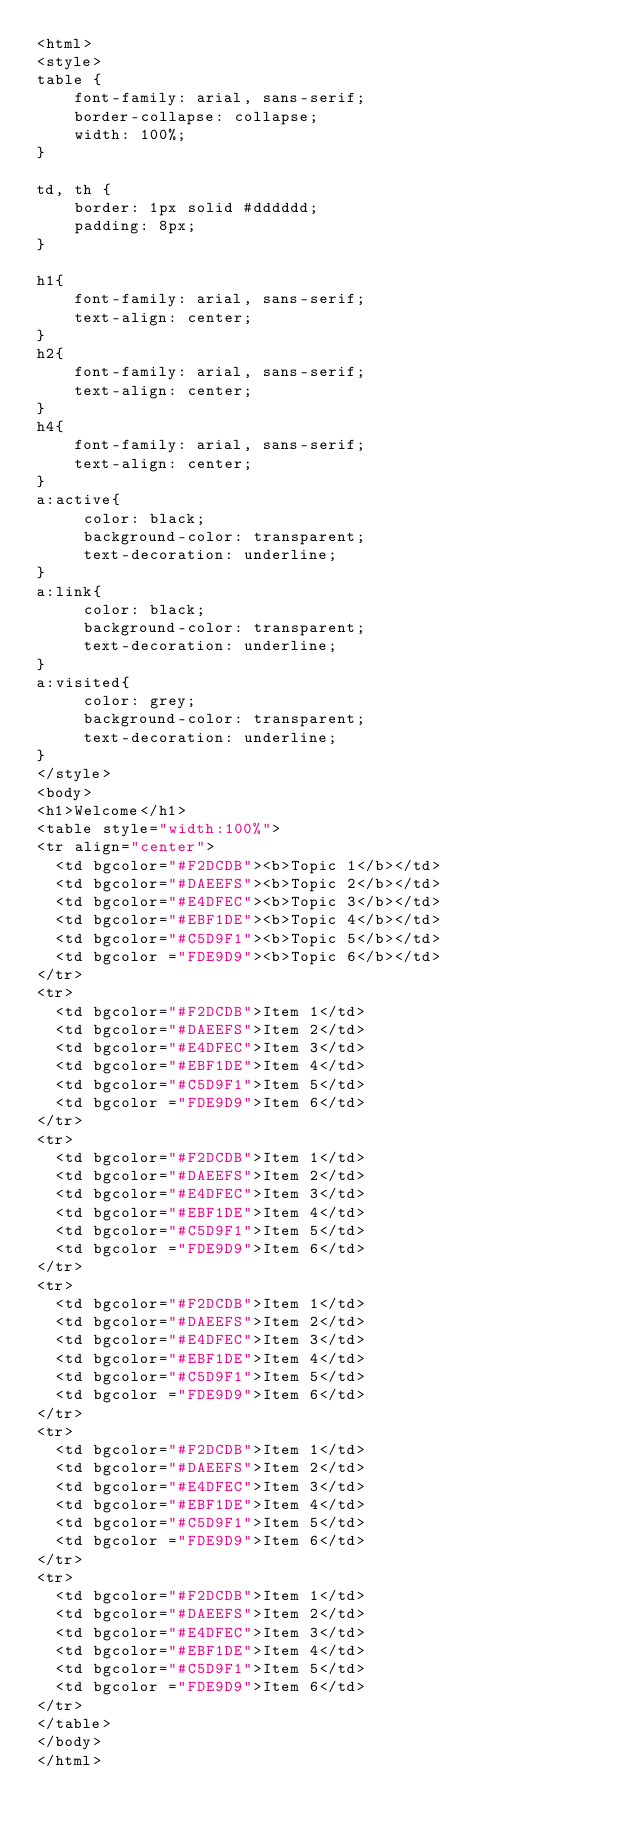Convert code to text. <code><loc_0><loc_0><loc_500><loc_500><_HTML_><html>
<style>
table {
    font-family: arial, sans-serif;
    border-collapse: collapse;
    width: 100%;
}

td, th {
    border: 1px solid #dddddd;
    padding: 8px;
}

h1{
    font-family: arial, sans-serif;
    text-align: center;
}
h2{
    font-family: arial, sans-serif;
    text-align: center;
}
h4{
    font-family: arial, sans-serif;
    text-align: center;
}
a:active{
     color: black;
     background-color: transparent;
     text-decoration: underline;
}
a:link{
     color: black;
     background-color: transparent;
     text-decoration: underline;
}
a:visited{
     color: grey;
     background-color: transparent;
     text-decoration: underline;
}
</style>
<body>
<h1>Welcome</h1>
<table style="width:100%">
<tr align="center">
  <td bgcolor="#F2DCDB"><b>Topic 1</b></td>
  <td bgcolor="#DAEEFS"><b>Topic 2</b></td>
  <td bgcolor="#E4DFEC"><b>Topic 3</b></td>
  <td bgcolor="#EBF1DE"><b>Topic 4</b></td>
  <td bgcolor="#C5D9F1"><b>Topic 5</b></td>
  <td bgcolor ="FDE9D9"><b>Topic 6</b></td>
</tr>
<tr>
  <td bgcolor="#F2DCDB">Item 1</td>
  <td bgcolor="#DAEEFS">Item 2</td>
  <td bgcolor="#E4DFEC">Item 3</td>
  <td bgcolor="#EBF1DE">Item 4</td>
  <td bgcolor="#C5D9F1">Item 5</td>
  <td bgcolor ="FDE9D9">Item 6</td>
</tr>
<tr>
  <td bgcolor="#F2DCDB">Item 1</td>
  <td bgcolor="#DAEEFS">Item 2</td>
  <td bgcolor="#E4DFEC">Item 3</td>
  <td bgcolor="#EBF1DE">Item 4</td>
  <td bgcolor="#C5D9F1">Item 5</td>
  <td bgcolor ="FDE9D9">Item 6</td>
</tr>
<tr>
  <td bgcolor="#F2DCDB">Item 1</td>
  <td bgcolor="#DAEEFS">Item 2</td>
  <td bgcolor="#E4DFEC">Item 3</td>
  <td bgcolor="#EBF1DE">Item 4</td>
  <td bgcolor="#C5D9F1">Item 5</td>
  <td bgcolor ="FDE9D9">Item 6</td>
</tr>
<tr>
  <td bgcolor="#F2DCDB">Item 1</td>
  <td bgcolor="#DAEEFS">Item 2</td>
  <td bgcolor="#E4DFEC">Item 3</td>
  <td bgcolor="#EBF1DE">Item 4</td>
  <td bgcolor="#C5D9F1">Item 5</td>
  <td bgcolor ="FDE9D9">Item 6</td>
</tr>
<tr>
  <td bgcolor="#F2DCDB">Item 1</td>
  <td bgcolor="#DAEEFS">Item 2</td>
  <td bgcolor="#E4DFEC">Item 3</td>
  <td bgcolor="#EBF1DE">Item 4</td>
  <td bgcolor="#C5D9F1">Item 5</td>
  <td bgcolor ="FDE9D9">Item 6</td>
</tr>
</table>
</body>
</html>
</code> 